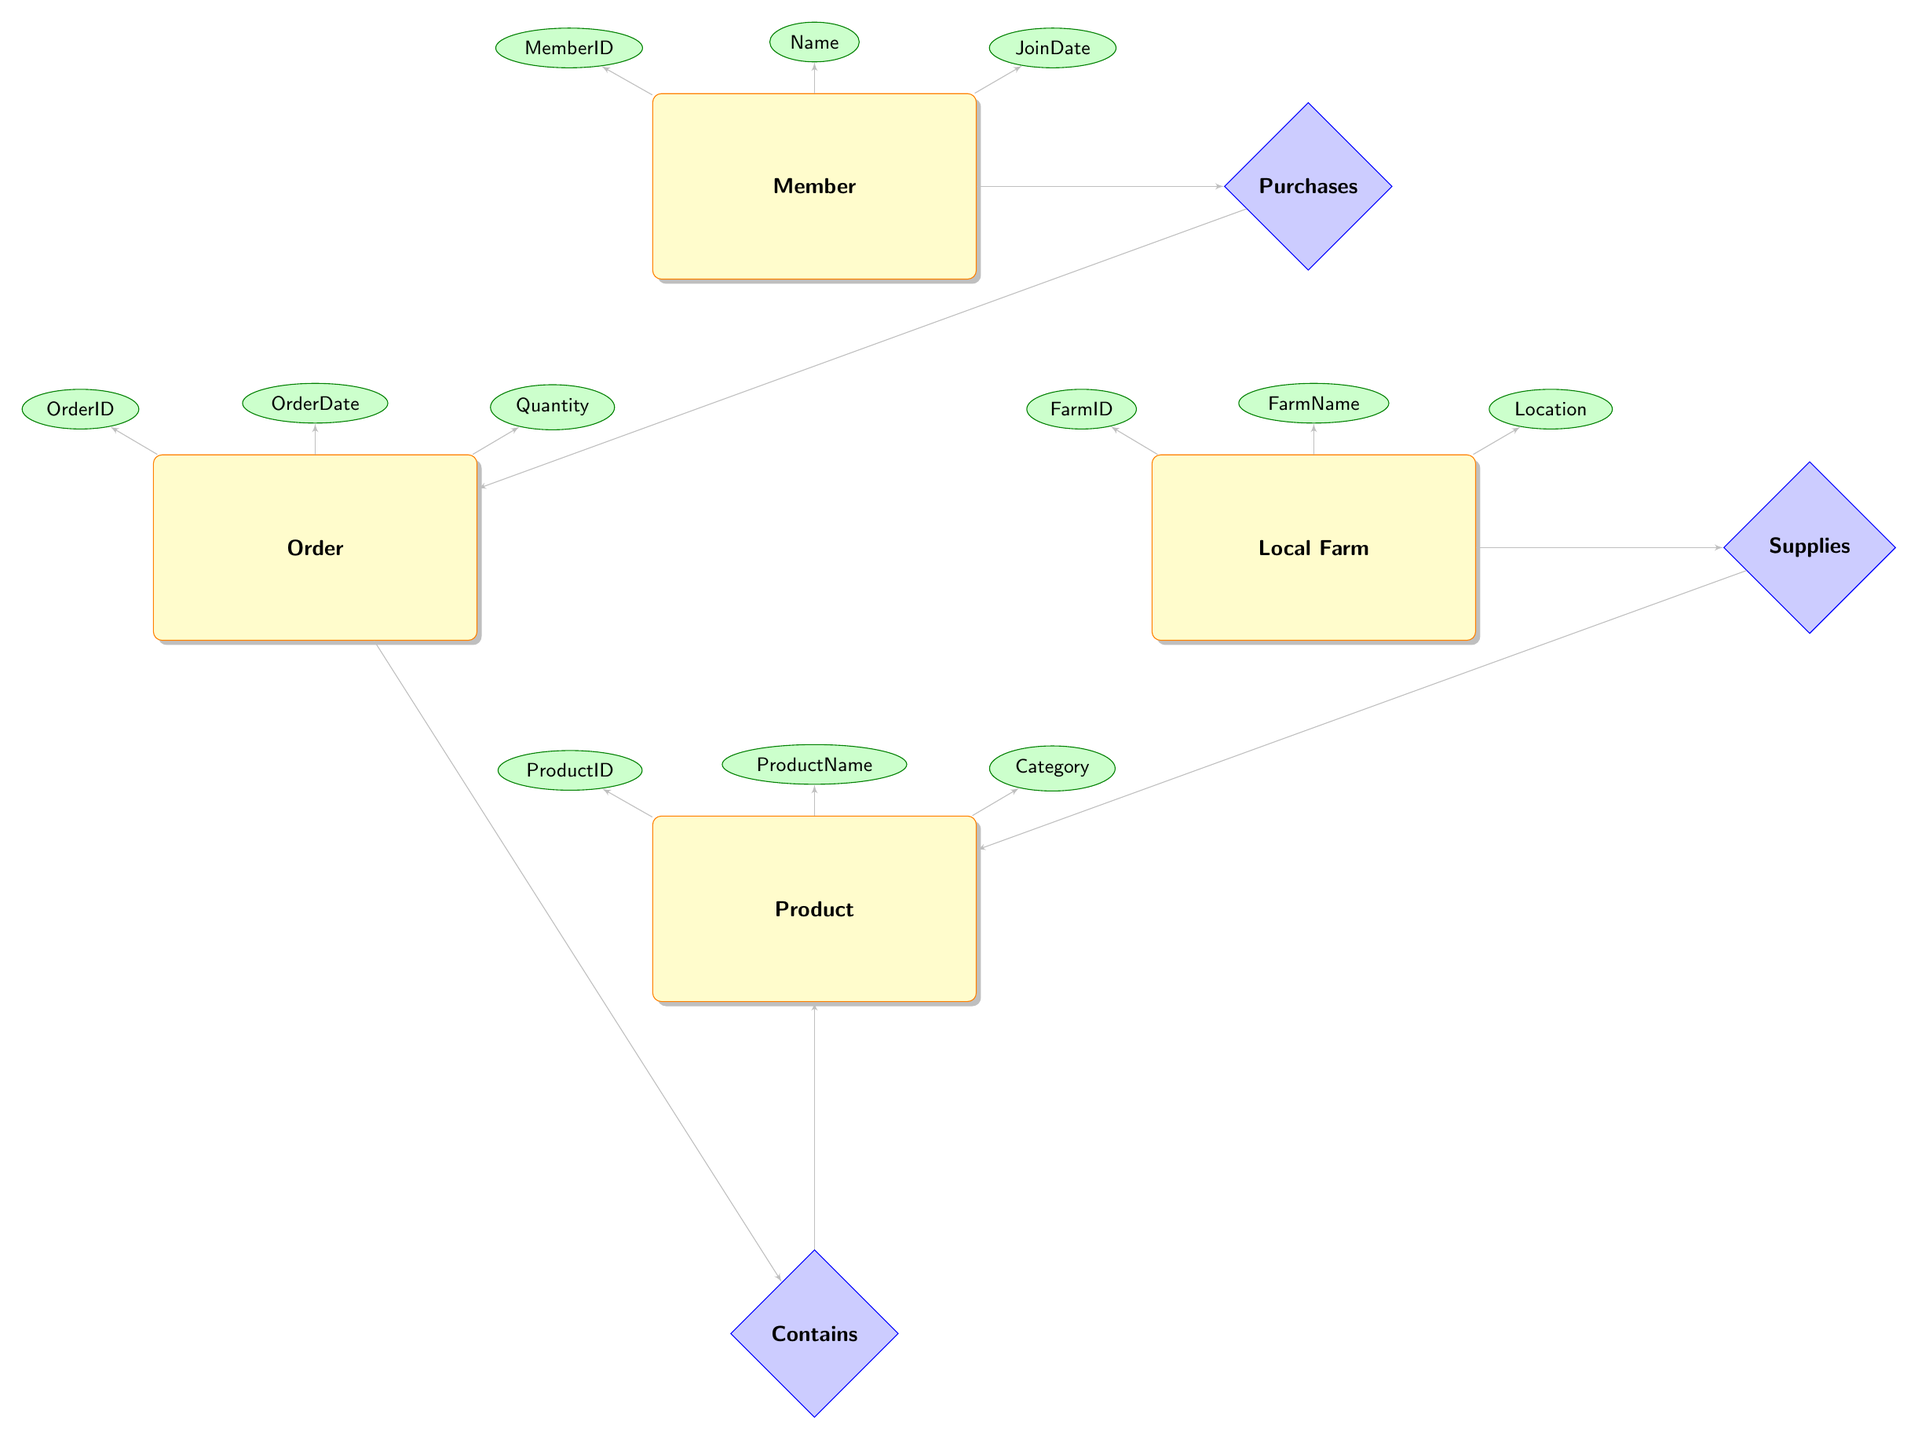What is the primary relationship between Local Farm and Product? The primary relationship between Local Farm and Product is labeled as "Supplies," indicating that local farms supply products.
Answer: Supplies How many attributes does the Member entity have? The Member entity has three attributes: MemberID, Name, and JoinDate. Count these attributes from the diagram.
Answer: Three What type of relationship exists between Member and Order? The relationship between Member and Order is labeled as "Purchases," which shows that members make purchases through their orders.
Answer: Purchases Which attributes belong to the Product entity? The attributes belonging to the Product entity are ProductID, ProductName, Category, and Price. Referring to the diagram, these attributes are connected to the Product entity.
Answer: ProductID, ProductName, Category, Price How many entities are represented in the diagram? The diagram represents four entities: Member, Local Farm, Product, and Order. By counting these, we confirm the total.
Answer: Four What is the purpose of the Contains relationship? The Contains relationship connects Order and Product, indicating that an order contains specific products. This relationship clarifies the contents of each order.
Answer: Indicates contents Which attribute of the Order entity indicates the date of the order? The attribute that indicates the date of the order is "OrderDate." This is explicitly associated with the Order entity within the diagram.
Answer: OrderDate Which relationship connects Local Farm to Product? The relationship that connects Local Farm to Product is "Supplies," which denotes the supply chain flow from local farms to the products offered.
Answer: Supplies Which member attribute would be useful for marketing outreach? The attribute "JoinDate" would be useful for marketing outreach, as it helps identify how long members have been engaged.
Answer: JoinDate What does the Quantity attribute represent in the Order entity? The Quantity attribute represents the amount of a product ordered. This is relevant to understanding order volumes and inventory.
Answer: Amount of product ordered 